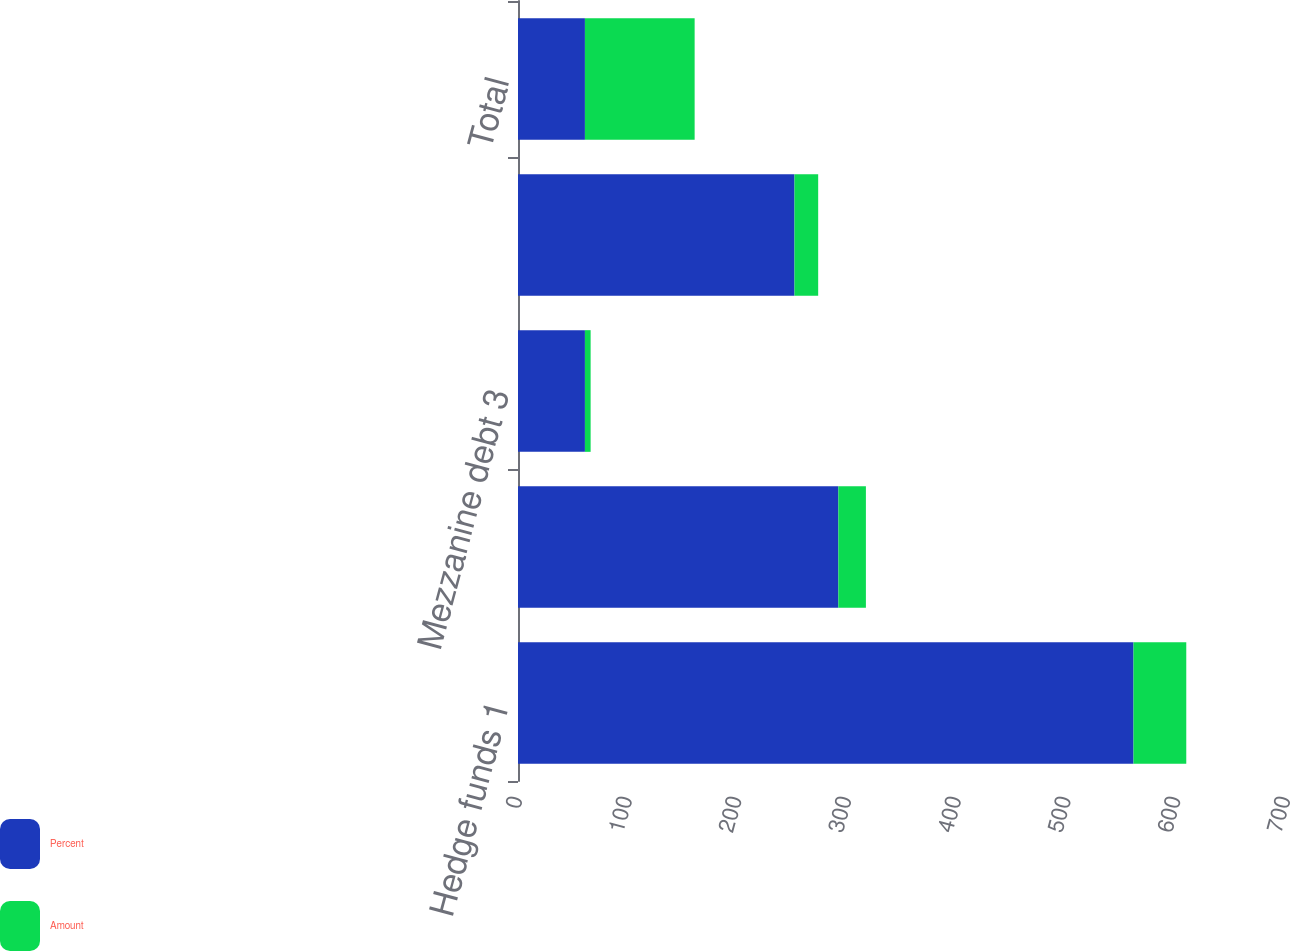<chart> <loc_0><loc_0><loc_500><loc_500><stacked_bar_chart><ecel><fcel>Hedge funds 1<fcel>Mortgage and real estate 2<fcel>Mezzanine debt 3<fcel>Private equity and other 4<fcel>Total<nl><fcel>Percent<fcel>561<fcel>292<fcel>61<fcel>252<fcel>61<nl><fcel>Amount<fcel>48.1<fcel>25.1<fcel>5.2<fcel>21.6<fcel>100<nl></chart> 